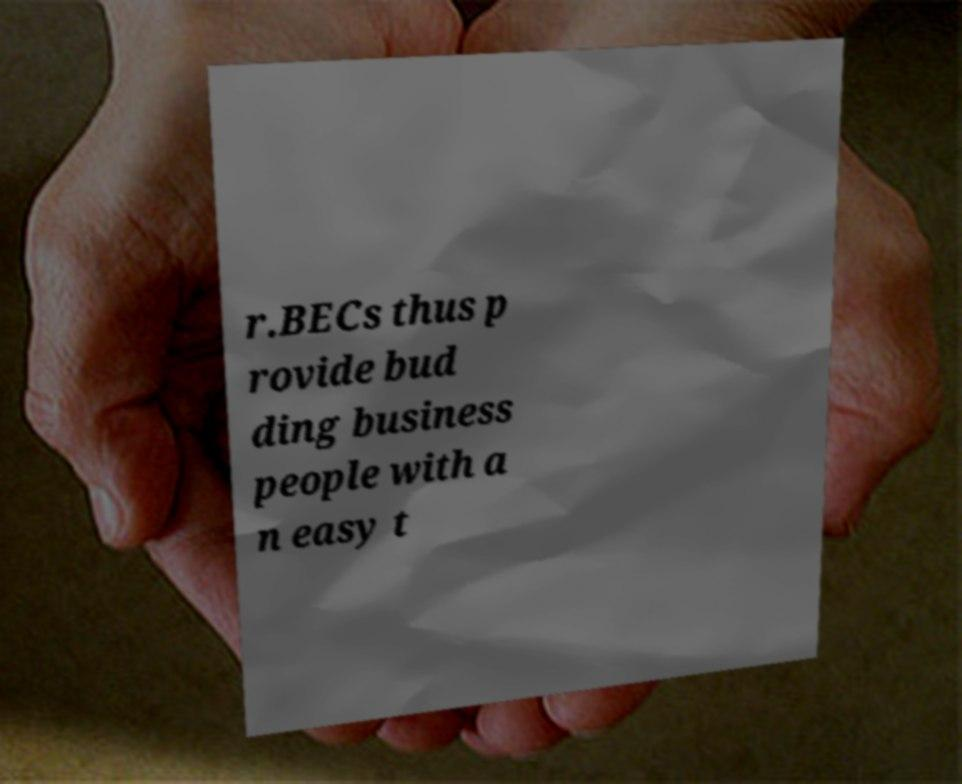Can you read and provide the text displayed in the image?This photo seems to have some interesting text. Can you extract and type it out for me? r.BECs thus p rovide bud ding business people with a n easy t 